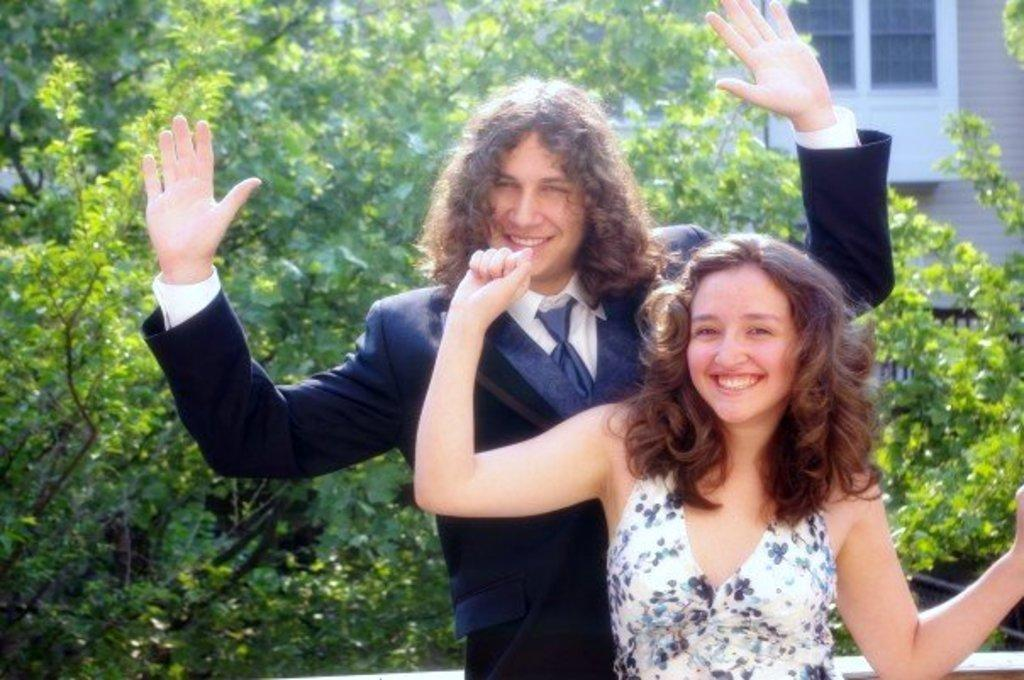How many people are present in the image? There is a lady and a man in the image, making a total of two people. What are the lady and man doing in the image? The lady and man are standing in the image. What can be seen in the background of the image? There are trees and a building in the background of the image. What type of pie is being served at the meeting in the image? There is no meeting or pie present in the image; it features a lady and a man standing with trees and a building in the background. 